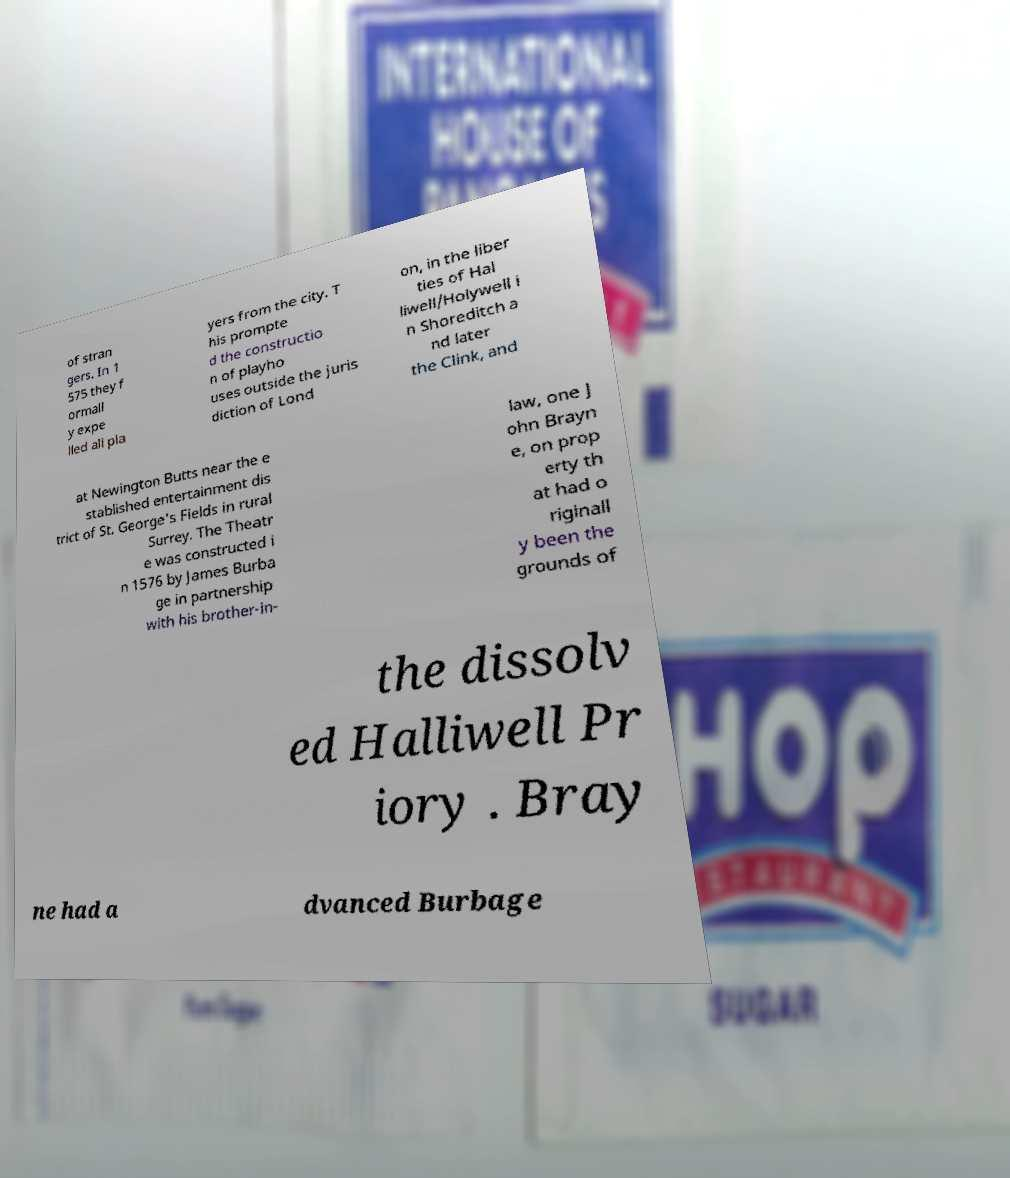For documentation purposes, I need the text within this image transcribed. Could you provide that? of stran gers. In 1 575 they f ormall y expe lled all pla yers from the city. T his prompte d the constructio n of playho uses outside the juris diction of Lond on, in the liber ties of Hal liwell/Holywell i n Shoreditch a nd later the Clink, and at Newington Butts near the e stablished entertainment dis trict of St. George's Fields in rural Surrey. The Theatr e was constructed i n 1576 by James Burba ge in partnership with his brother-in- law, one J ohn Brayn e, on prop erty th at had o riginall y been the grounds of the dissolv ed Halliwell Pr iory . Bray ne had a dvanced Burbage 